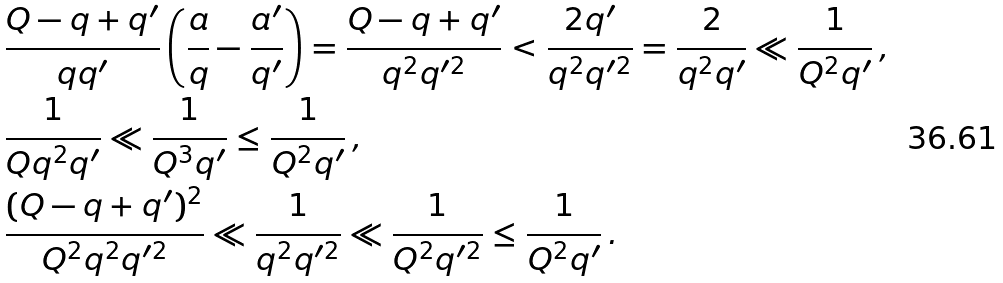Convert formula to latex. <formula><loc_0><loc_0><loc_500><loc_500>& \frac { Q - q + q ^ { \prime } } { q q ^ { \prime } } \left ( \frac { a } { q } - \frac { a ^ { \prime } } { q ^ { \prime } } \right ) = \frac { Q - q + q ^ { \prime } } { q ^ { 2 } q ^ { \prime 2 } } < \frac { 2 q ^ { \prime } } { q ^ { 2 } q ^ { \prime 2 } } = \frac { 2 } { q ^ { 2 } q ^ { \prime } } \ll \frac { 1 } { Q ^ { 2 } q ^ { \prime } } \, , \\ & \frac { 1 } { Q q ^ { 2 } q ^ { \prime } } \ll \frac { 1 } { Q ^ { 3 } q ^ { \prime } } \leq \frac { 1 } { Q ^ { 2 } q ^ { \prime } } \, , \\ & \frac { ( Q - q + q ^ { \prime } ) ^ { 2 } } { Q ^ { 2 } q ^ { 2 } q ^ { \prime 2 } } \ll \frac { 1 } { q ^ { 2 } q ^ { \prime 2 } } \ll \frac { 1 } { Q ^ { 2 } q ^ { \prime 2 } } \leq \frac { 1 } { Q ^ { 2 } q ^ { \prime } } \, .</formula> 